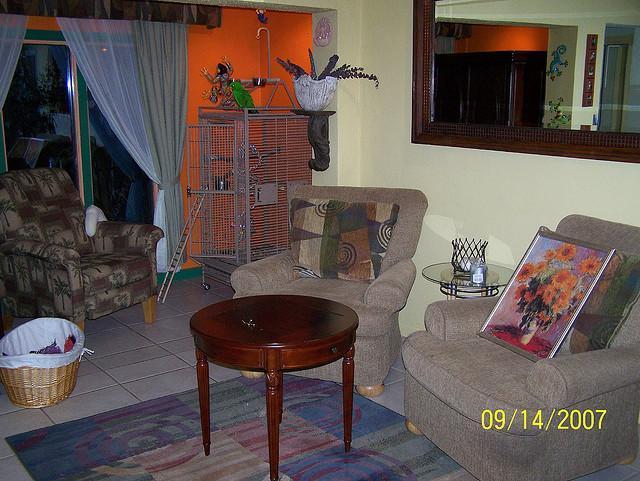How many chairs are there?
Give a very brief answer. 3. How many trains are in the image?
Give a very brief answer. 0. 